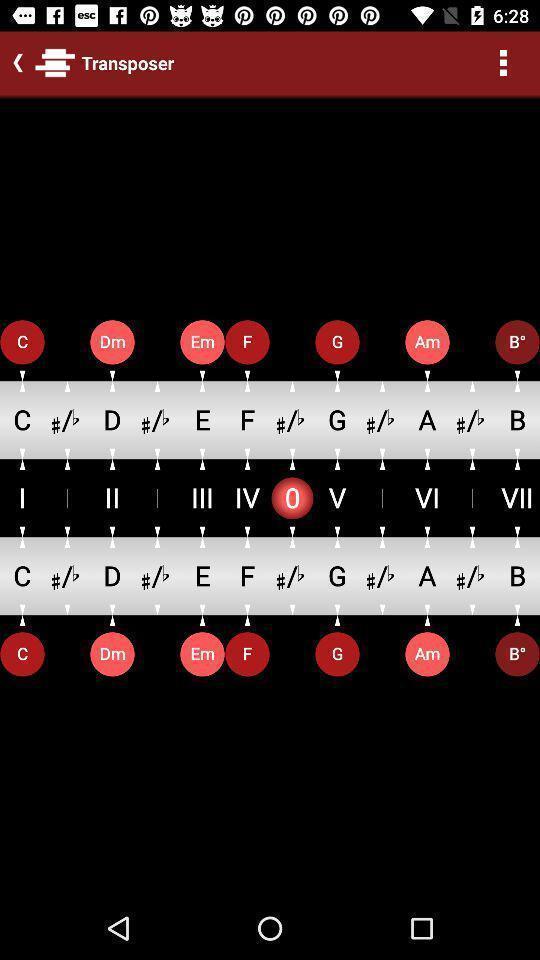Describe the key features of this screenshot. Screen showing transposer in an musical application. 